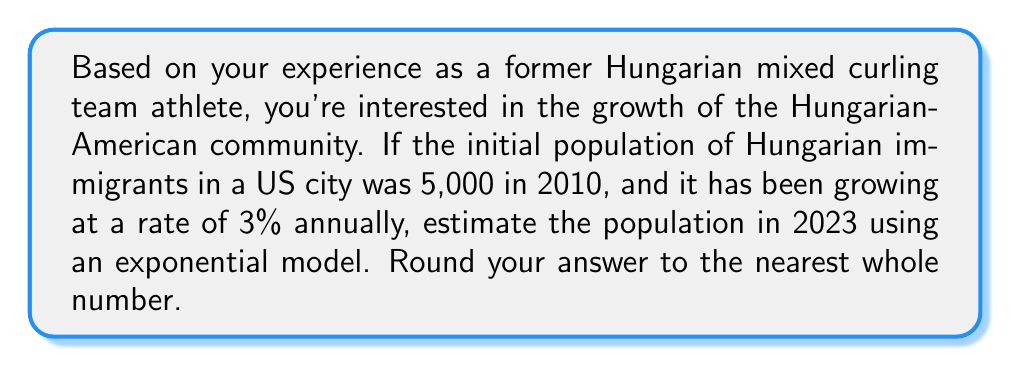Can you solve this math problem? Let's approach this step-by-step using an exponential growth model:

1) The exponential growth formula is:
   $$A = P(1 + r)^t$$
   Where:
   $A$ = Final amount
   $P$ = Initial principal balance
   $r$ = Growth rate (as a decimal)
   $t$ = Time period

2) We know:
   $P = 5,000$ (initial population in 2010)
   $r = 0.03$ (3% annual growth rate)
   $t = 13$ (years from 2010 to 2023)

3) Let's plug these values into our formula:
   $$A = 5,000(1 + 0.03)^{13}$$

4) Simplify inside the parentheses:
   $$A = 5,000(1.03)^{13}$$

5) Calculate $(1.03)^{13}$:
   $$1.03^{13} \approx 1.4685$$

6) Multiply by 5,000:
   $$A = 5,000 \times 1.4685 = 7,342.5$$

7) Rounding to the nearest whole number:
   $$A \approx 7,343$$
Answer: 7,343 